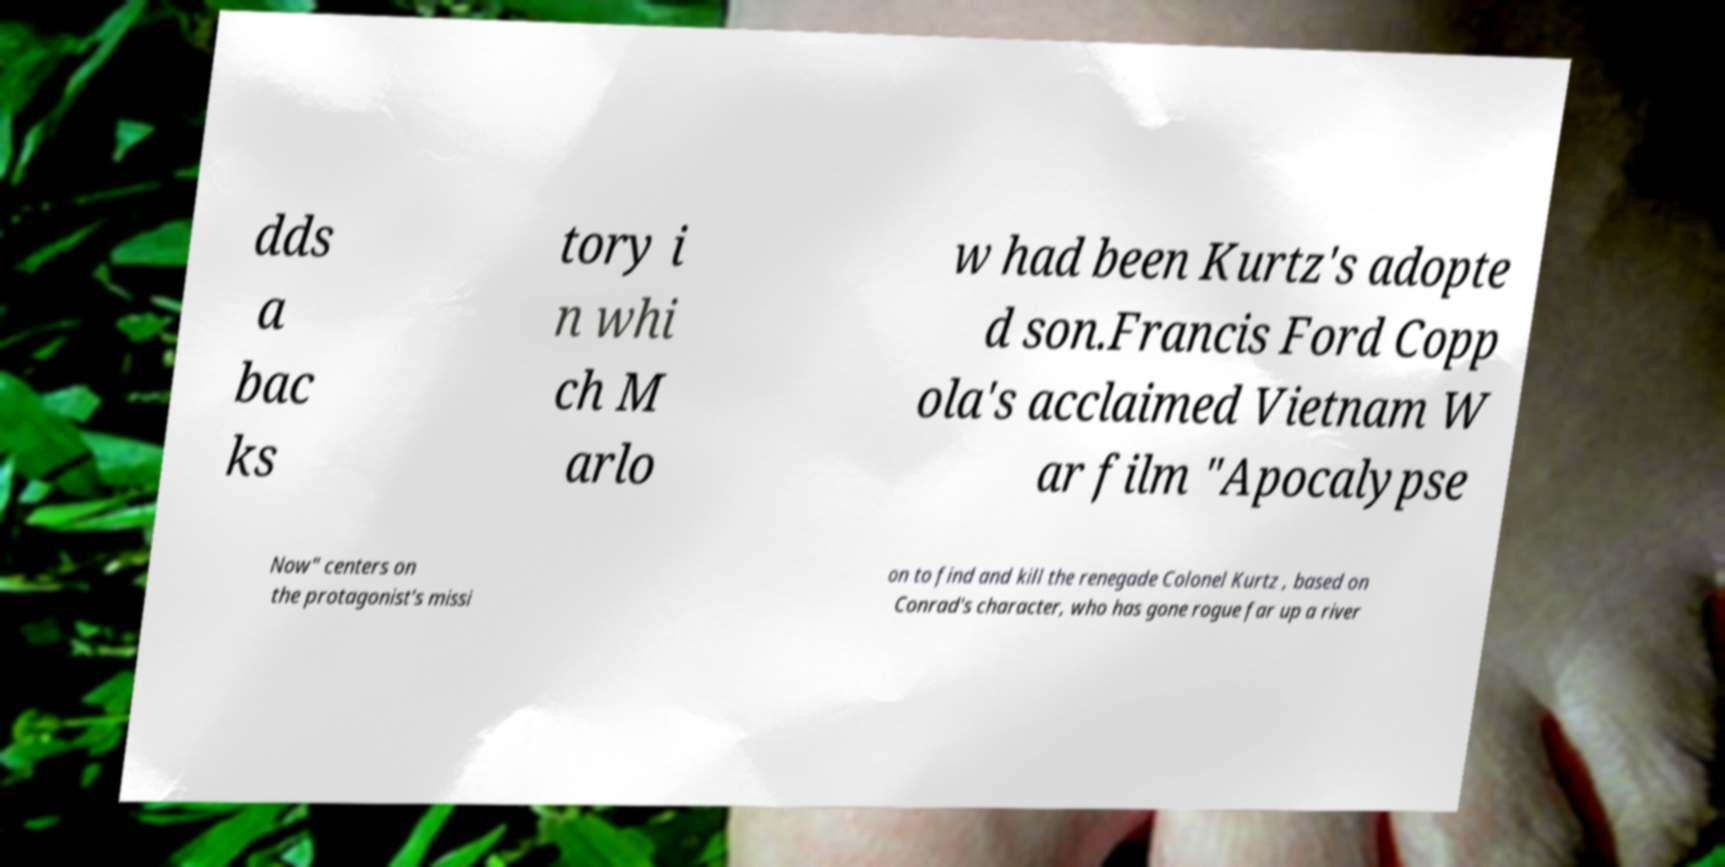There's text embedded in this image that I need extracted. Can you transcribe it verbatim? dds a bac ks tory i n whi ch M arlo w had been Kurtz's adopte d son.Francis Ford Copp ola's acclaimed Vietnam W ar film "Apocalypse Now" centers on the protagonist's missi on to find and kill the renegade Colonel Kurtz , based on Conrad's character, who has gone rogue far up a river 